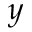Convert formula to latex. <formula><loc_0><loc_0><loc_500><loc_500>y</formula> 